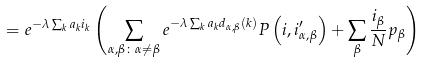<formula> <loc_0><loc_0><loc_500><loc_500>= e ^ { - \lambda \sum _ { k } a _ { k } i _ { k } } \left ( \sum _ { \alpha , \beta \colon \alpha \neq \beta } e ^ { - \lambda \sum _ { k } a _ { k } d _ { \alpha , \beta } \left ( k \right ) } P \left ( i , i _ { \alpha , \beta } ^ { \prime } \right ) + \sum _ { \beta } \frac { i _ { \beta } } { N } p _ { \beta } \right )</formula> 